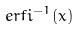<formula> <loc_0><loc_0><loc_500><loc_500>e r f i ^ { - 1 } ( x )</formula> 